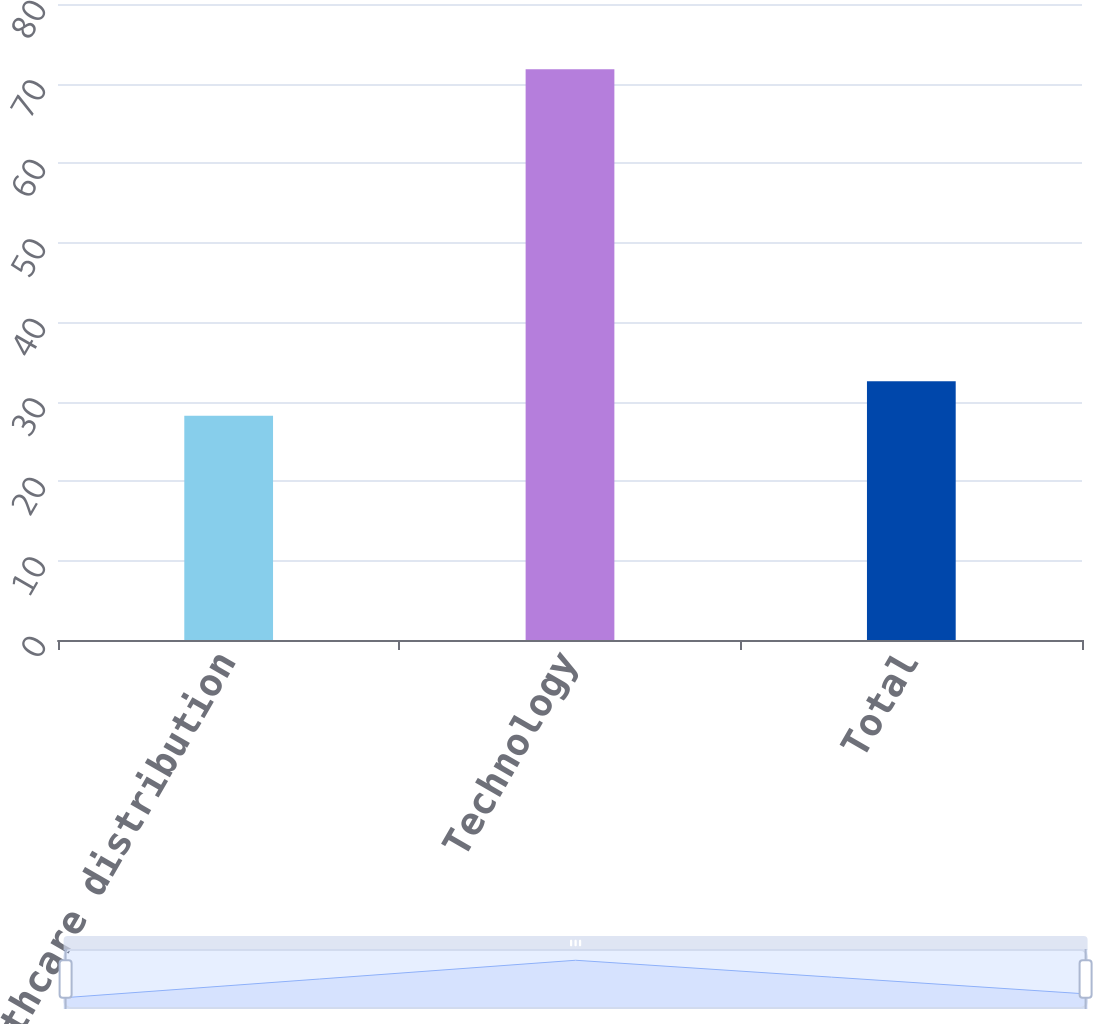Convert chart to OTSL. <chart><loc_0><loc_0><loc_500><loc_500><bar_chart><fcel>Healthcare distribution<fcel>Technology<fcel>Total<nl><fcel>28.2<fcel>71.8<fcel>32.56<nl></chart> 